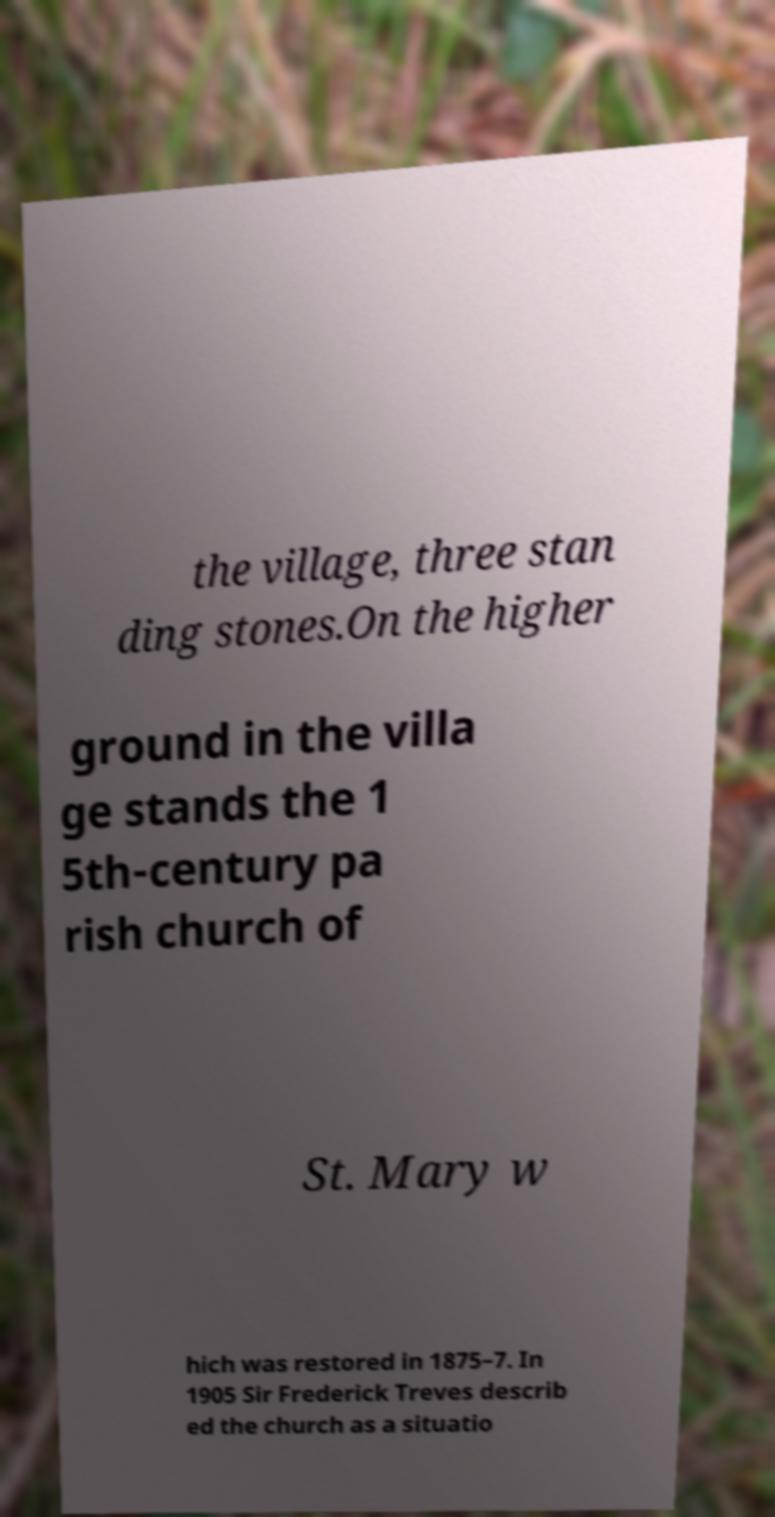For documentation purposes, I need the text within this image transcribed. Could you provide that? the village, three stan ding stones.On the higher ground in the villa ge stands the 1 5th-century pa rish church of St. Mary w hich was restored in 1875–7. In 1905 Sir Frederick Treves describ ed the church as a situatio 